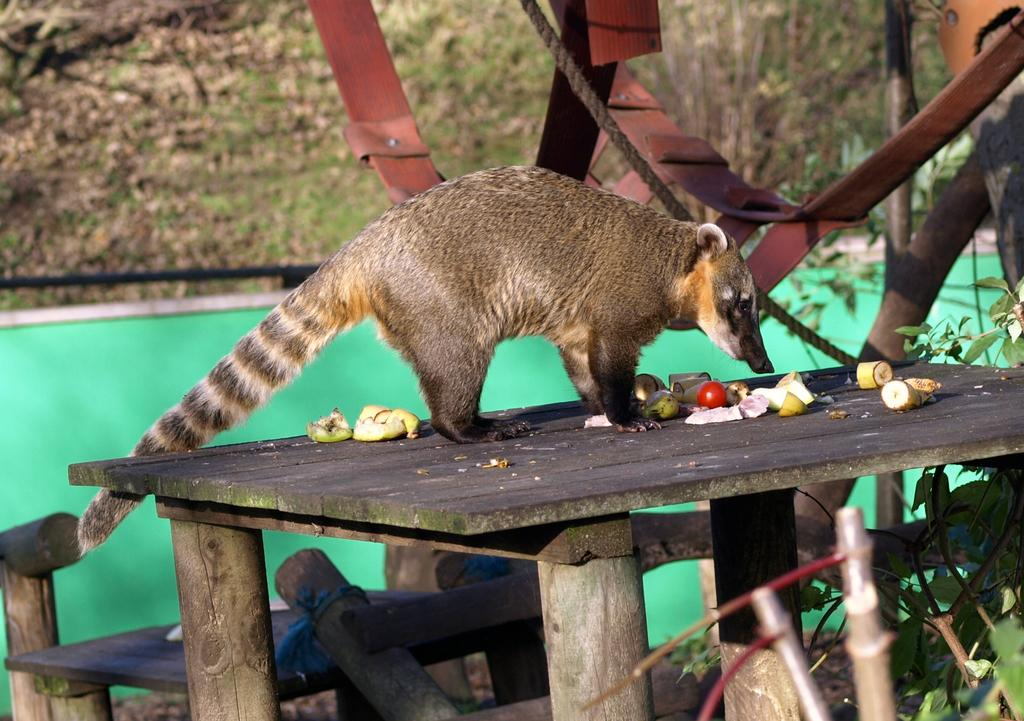What animal is on the wooden table in the image? There is a mongoose on the wooden table in the image. What else can be seen on the table besides the mongoose? There are fruits and tomatoes on the table. What type of objects are visible at the top of the image? There are iron things visible at the top of the image. What type of grain is being harvested in the image? There is no grain or harvesting activity present in the image. What type of competition is taking place in the image? There is no competition present in the image. 